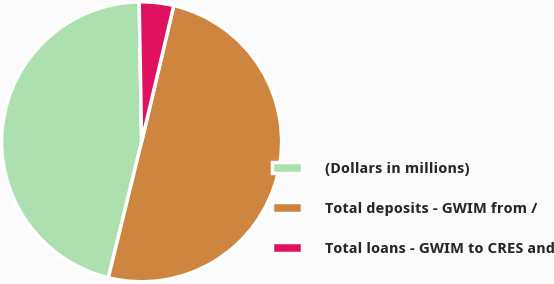Convert chart. <chart><loc_0><loc_0><loc_500><loc_500><pie_chart><fcel>(Dollars in millions)<fcel>Total deposits - GWIM from /<fcel>Total loans - GWIM to CRES and<nl><fcel>45.89%<fcel>50.13%<fcel>3.97%<nl></chart> 